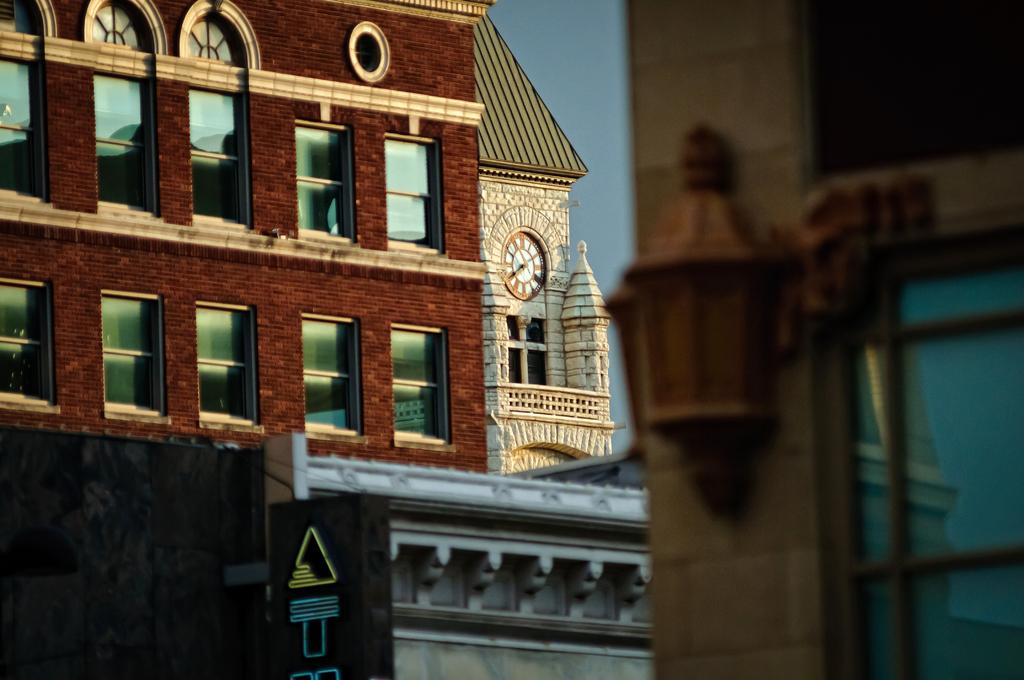What type of structures are present in the image? There are buildings in the image. Can you describe the light source in the image? Yes, there is a light source in the image. What object can be seen in the image that might be used for displaying information? There is a board in the image that could be used for displaying information. Where is the clock located in the image? The clock is on the wall in the image. What can be seen in the background of the image? The sky is visible in the background of the image. What type of harmony is being practiced by the earth in the image? There is no reference to the earth or harmony in the image; it features buildings, a light source, a board, a clock, and the sky. 